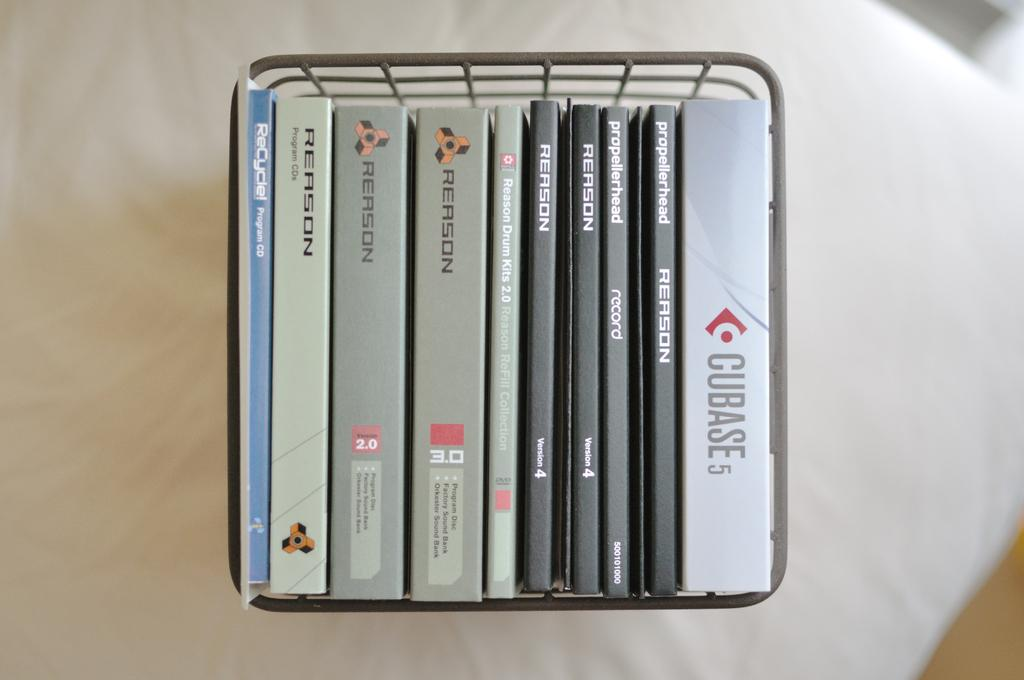<image>
Describe the image concisely. A metal basket that contains CD AND DVD cases that have Cubase 5 and Reason written on some of them. 